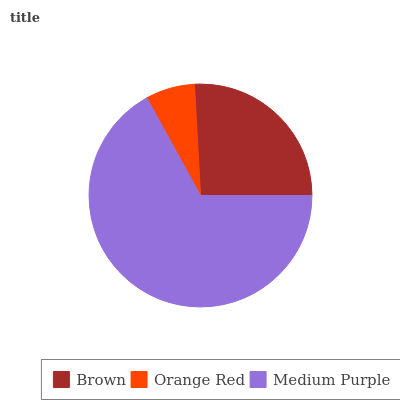Is Orange Red the minimum?
Answer yes or no. Yes. Is Medium Purple the maximum?
Answer yes or no. Yes. Is Medium Purple the minimum?
Answer yes or no. No. Is Orange Red the maximum?
Answer yes or no. No. Is Medium Purple greater than Orange Red?
Answer yes or no. Yes. Is Orange Red less than Medium Purple?
Answer yes or no. Yes. Is Orange Red greater than Medium Purple?
Answer yes or no. No. Is Medium Purple less than Orange Red?
Answer yes or no. No. Is Brown the high median?
Answer yes or no. Yes. Is Brown the low median?
Answer yes or no. Yes. Is Orange Red the high median?
Answer yes or no. No. Is Medium Purple the low median?
Answer yes or no. No. 